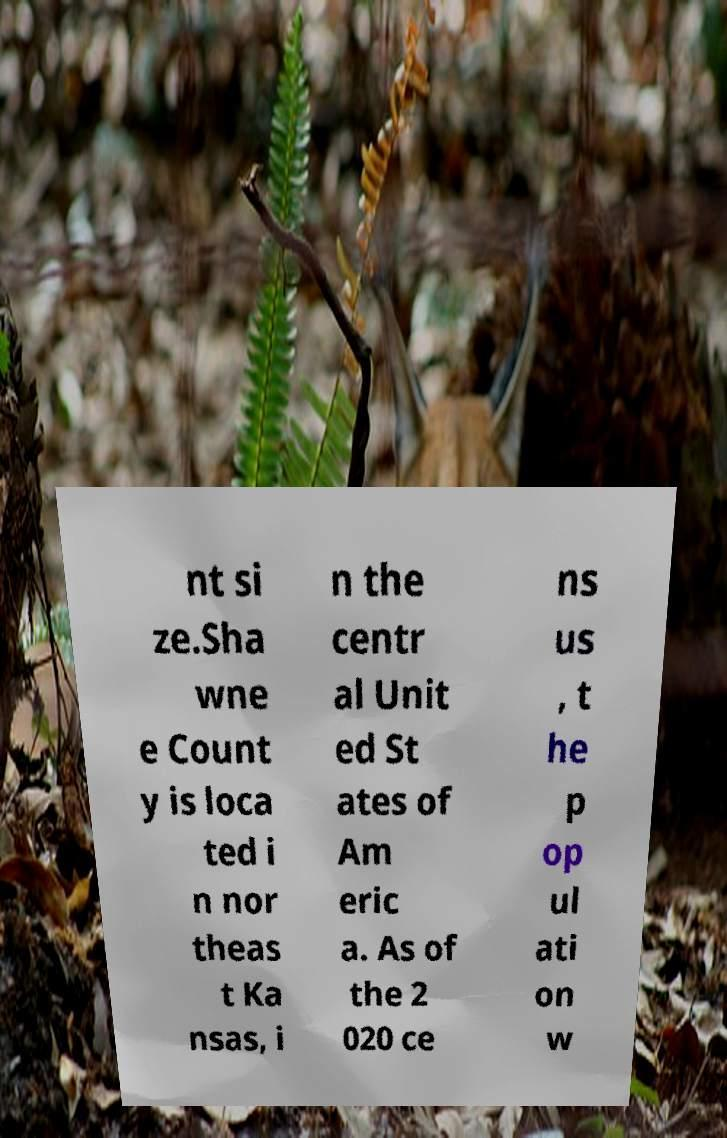Can you read and provide the text displayed in the image?This photo seems to have some interesting text. Can you extract and type it out for me? nt si ze.Sha wne e Count y is loca ted i n nor theas t Ka nsas, i n the centr al Unit ed St ates of Am eric a. As of the 2 020 ce ns us , t he p op ul ati on w 